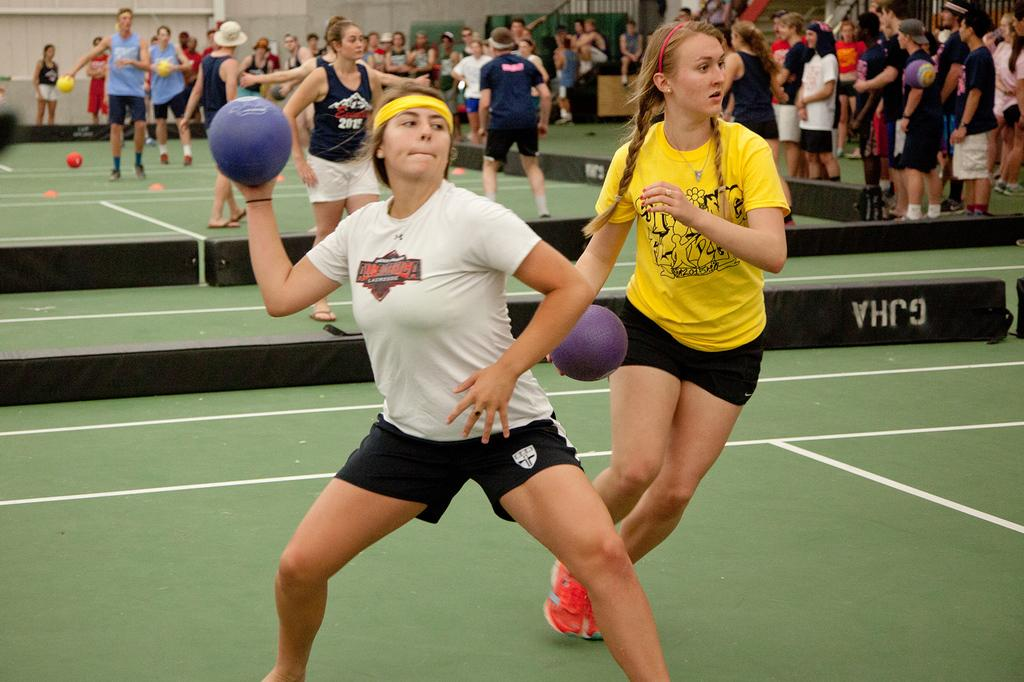What are the people in the image doing? There are groups of people standing in the image, and some of them are holding balls. What color are the objects placed on the floor? The black color objects are placed on the floor. What type of drain can be seen in the image? There is no drain present in the image. What is the glass used for in the image? There is no glass present in the image. 